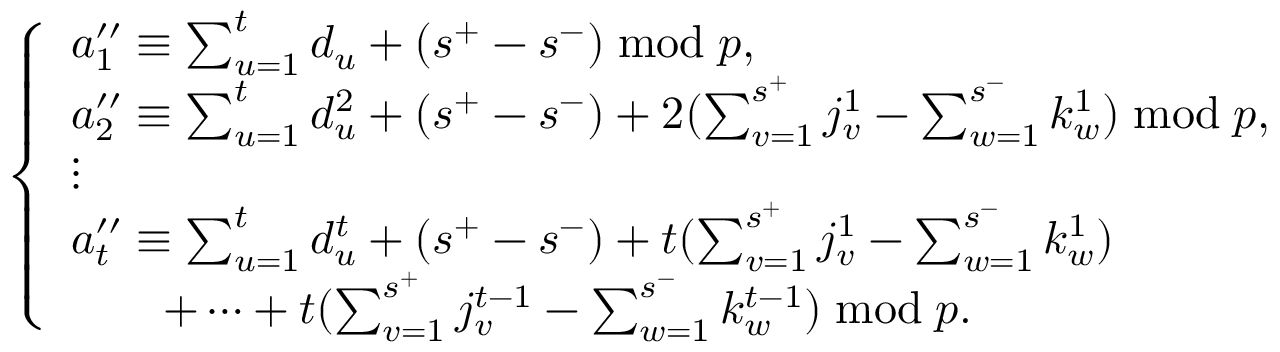Convert formula to latex. <formula><loc_0><loc_0><loc_500><loc_500>\left \{ \begin{array} { l l } { a _ { 1 } ^ { \prime \prime } \equiv \sum _ { u = 1 } ^ { t } d _ { u } + ( s ^ { + } - s ^ { - } ) \bmod p , } \\ { a _ { 2 } ^ { \prime \prime } \equiv \sum _ { u = 1 } ^ { t } d _ { u } ^ { 2 } + ( s ^ { + } - s ^ { - } ) + 2 ( \sum _ { v = 1 } ^ { s ^ { + } } j _ { v } ^ { 1 } - \sum _ { w = 1 } ^ { s ^ { - } } k _ { w } ^ { 1 } ) \bmod p , } \\ { \vdots } \\ { a _ { t } ^ { \prime \prime } \equiv \sum _ { u = 1 } ^ { t } d _ { u } ^ { t } + ( s ^ { + } - s ^ { - } ) + t ( \sum _ { v = 1 } ^ { s ^ { + } } j _ { v } ^ { 1 } - \sum _ { w = 1 } ^ { s ^ { - } } k _ { w } ^ { 1 } ) } \\ { \quad + \dots m + t ( \sum _ { v = 1 } ^ { s ^ { + } } j _ { v } ^ { t - 1 } - \sum _ { w = 1 } ^ { s ^ { - } } k _ { w } ^ { t - 1 } ) \bmod p . } \end{array}</formula> 